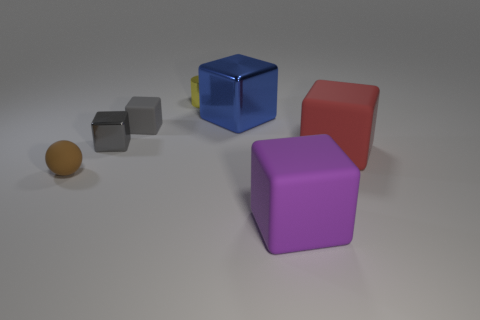Subtract all small cubes. How many cubes are left? 3 Subtract all gray cylinders. How many gray cubes are left? 2 Add 2 gray spheres. How many objects exist? 9 Subtract all blue blocks. How many blocks are left? 4 Subtract all balls. How many objects are left? 6 Add 6 red objects. How many red objects are left? 7 Add 2 small gray shiny spheres. How many small gray shiny spheres exist? 2 Subtract 0 green balls. How many objects are left? 7 Subtract all blue cubes. Subtract all red spheres. How many cubes are left? 4 Subtract all tiny green cylinders. Subtract all gray objects. How many objects are left? 5 